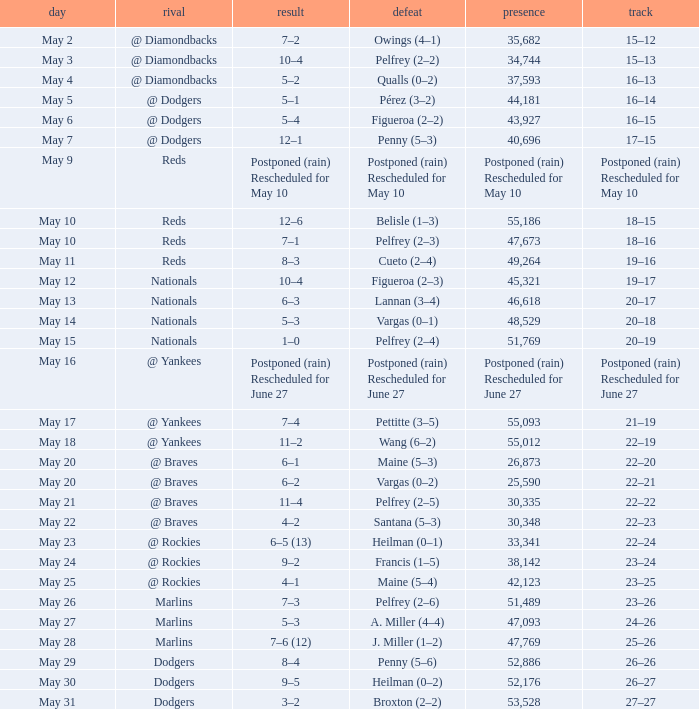Opponent of @ braves, and a Loss of pelfrey (2–5) had what score? 11–4. 